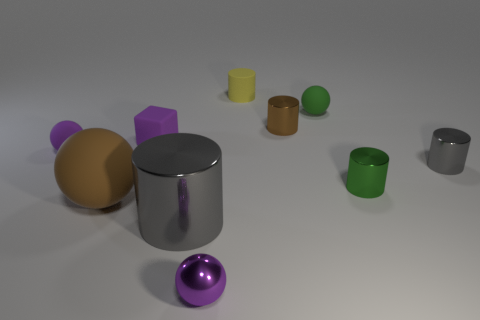Subtract 3 cylinders. How many cylinders are left? 2 Subtract all green cylinders. How many cylinders are left? 4 Subtract all brown cylinders. How many cylinders are left? 4 Subtract all yellow cylinders. Subtract all red cubes. How many cylinders are left? 4 Subtract all cubes. How many objects are left? 9 Subtract 1 yellow cylinders. How many objects are left? 9 Subtract all big cyan blocks. Subtract all small blocks. How many objects are left? 9 Add 1 tiny balls. How many tiny balls are left? 4 Add 8 tiny red rubber cubes. How many tiny red rubber cubes exist? 8 